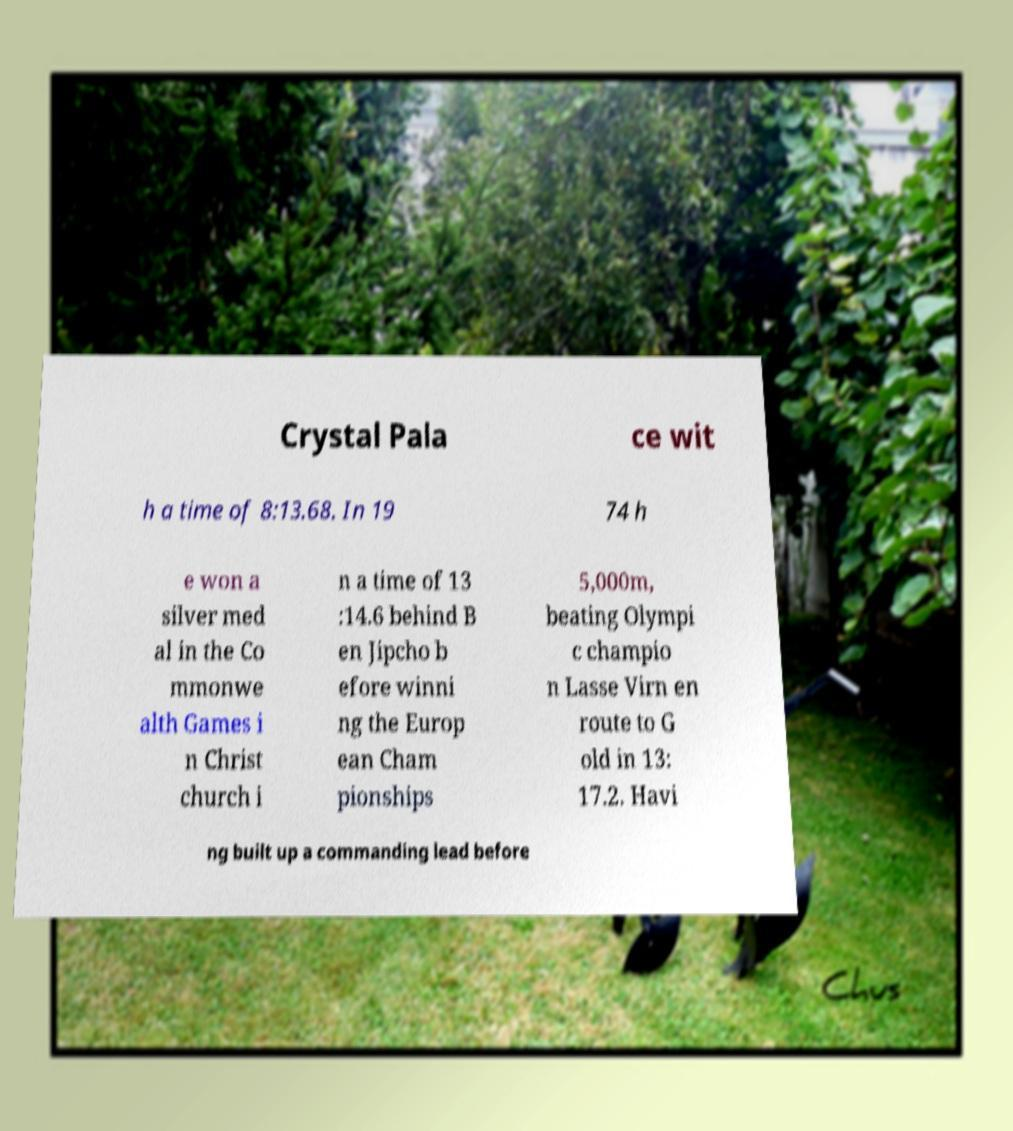I need the written content from this picture converted into text. Can you do that? Crystal Pala ce wit h a time of 8:13.68. In 19 74 h e won a silver med al in the Co mmonwe alth Games i n Christ church i n a time of 13 :14.6 behind B en Jipcho b efore winni ng the Europ ean Cham pionships 5,000m, beating Olympi c champio n Lasse Virn en route to G old in 13: 17.2. Havi ng built up a commanding lead before 